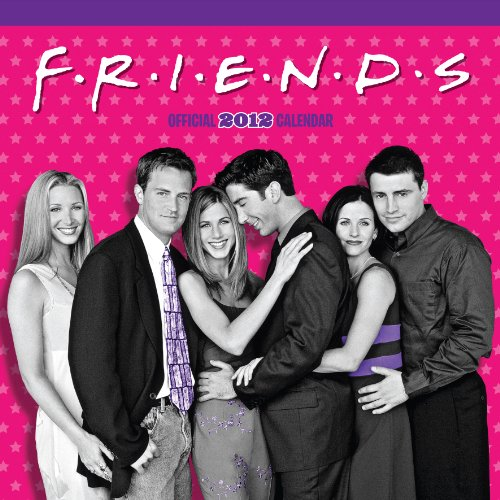What is the title of this book? The item is titled 'Official Friends TV Calendar 2012', featuring themed images from the popular TV show 'Friends' for each month of the year. 